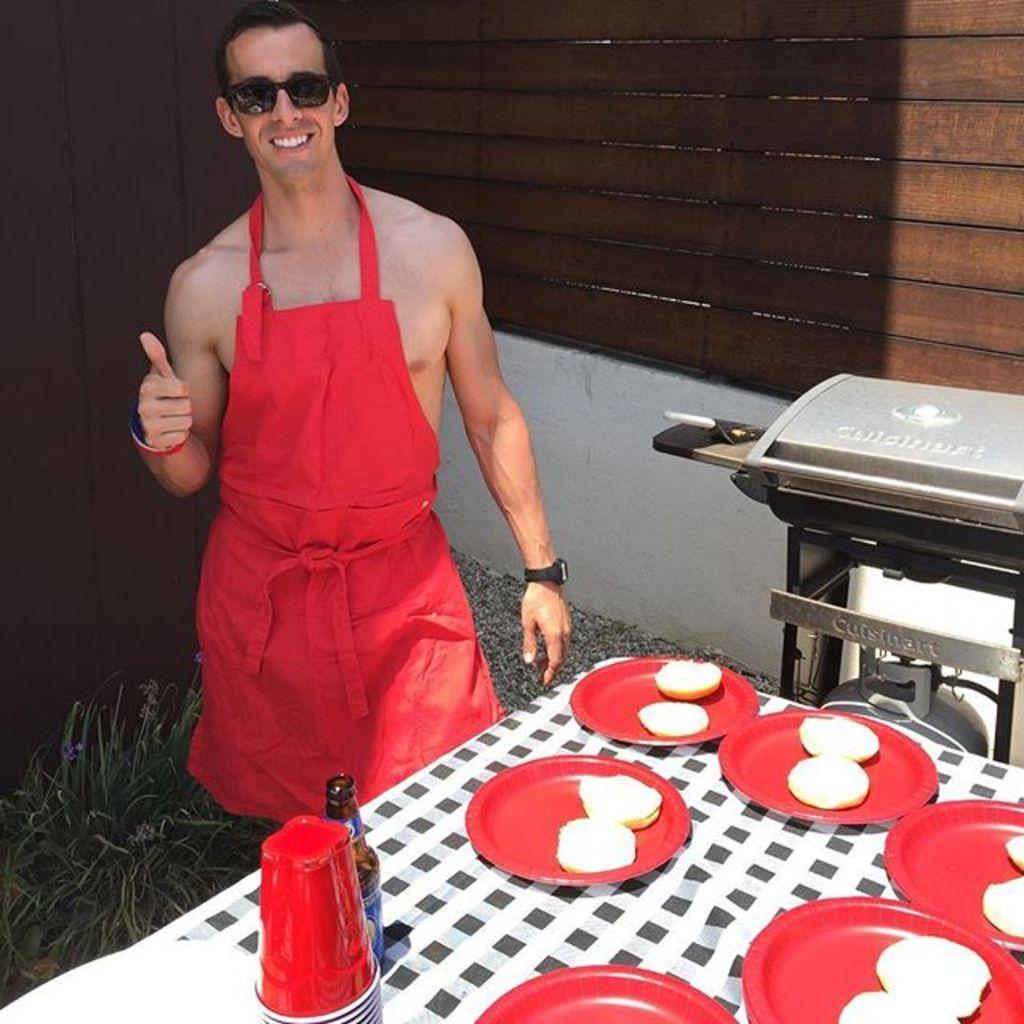Describe this image in one or two sentences. In this picture we can see a man standing and smiling, there is a table in front of him, we can see some plates and a bottle present on the table, we can see some food in these plates, at the bottom there is a plant, in the background we can see a wall. 